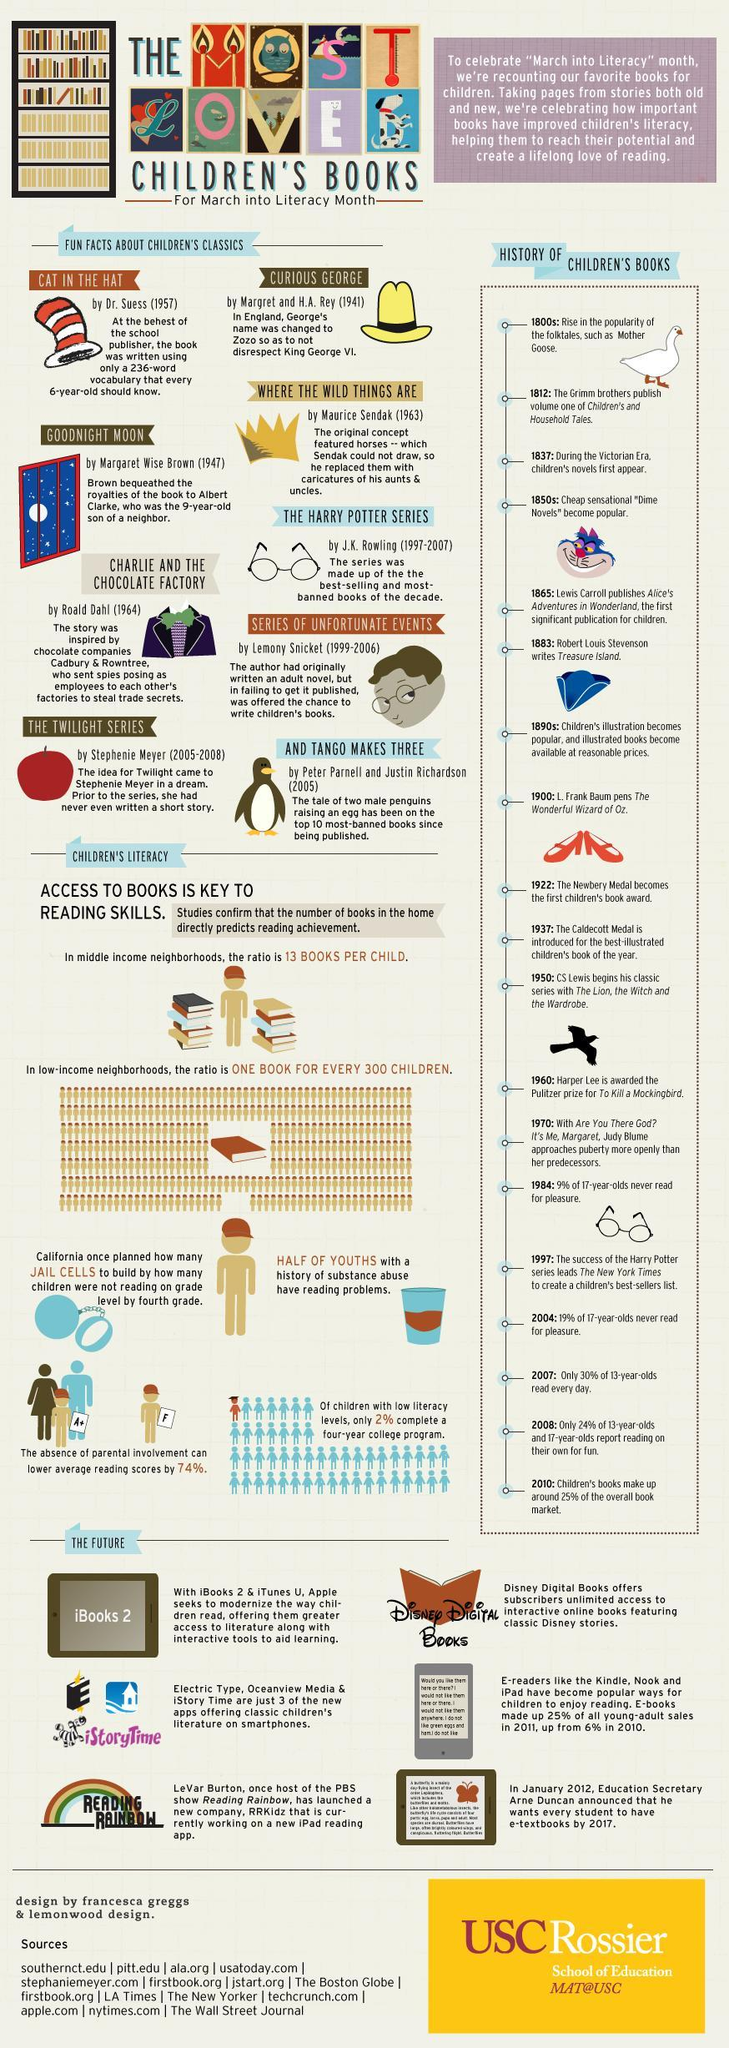When was the story of Alice in Wonderland published, 1964, 1999, or 1865?
Answer the question with a short phrase. 1865 Which book contained words children aged six were familiar with, Curious George, Charlie and the Chocolate factory, or Cat in the Hat? Cat in the hat 